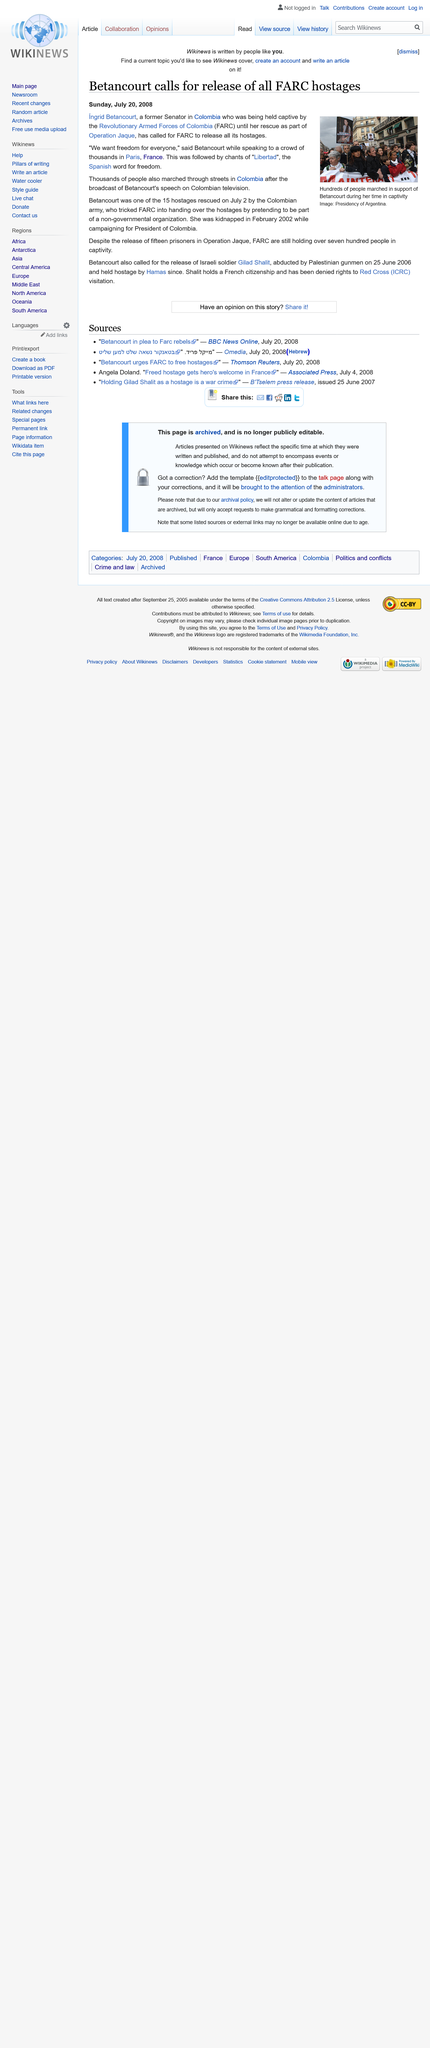Highlight a few significant elements in this photo. Libertad is the Spanish word for freedom, and it is a value that is highly cherished by the people of Spain and many other countries around the world. Freedom is a precious right that is essential for the pursuit of happiness and personal fulfillment, and it is something that should be protected and celebrated by all. The Revolutionary Armed Forces of Colombia, commonly known as the FARC, is the real name of this organization. Ingrid Betancourt was kidnapped in February 2002. 